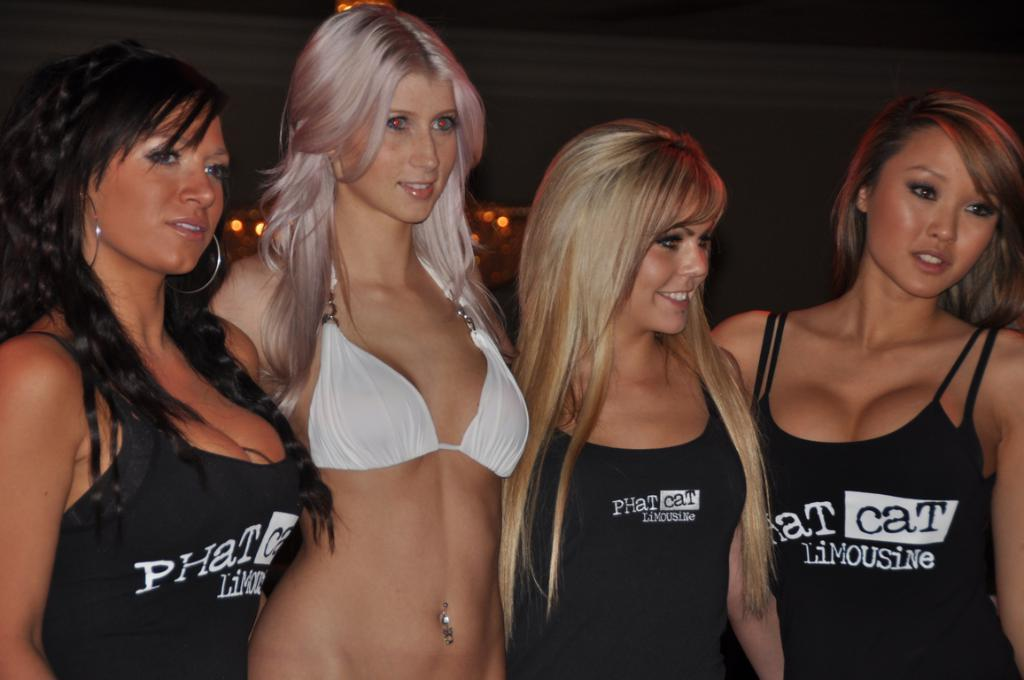How many women are present in the image? There are four women in the image. What is the color of the dresses worn by three of the women? Three of the women are wearing black color dresses. What is the facial expression of the women in the image? All the women are smiling. Can you describe the background of the image? The background of the image is dark. What type of tank can be seen in the image? There is no tank present in the image. What religious symbol can be seen in the image? There is no religious symbol present in the image. 